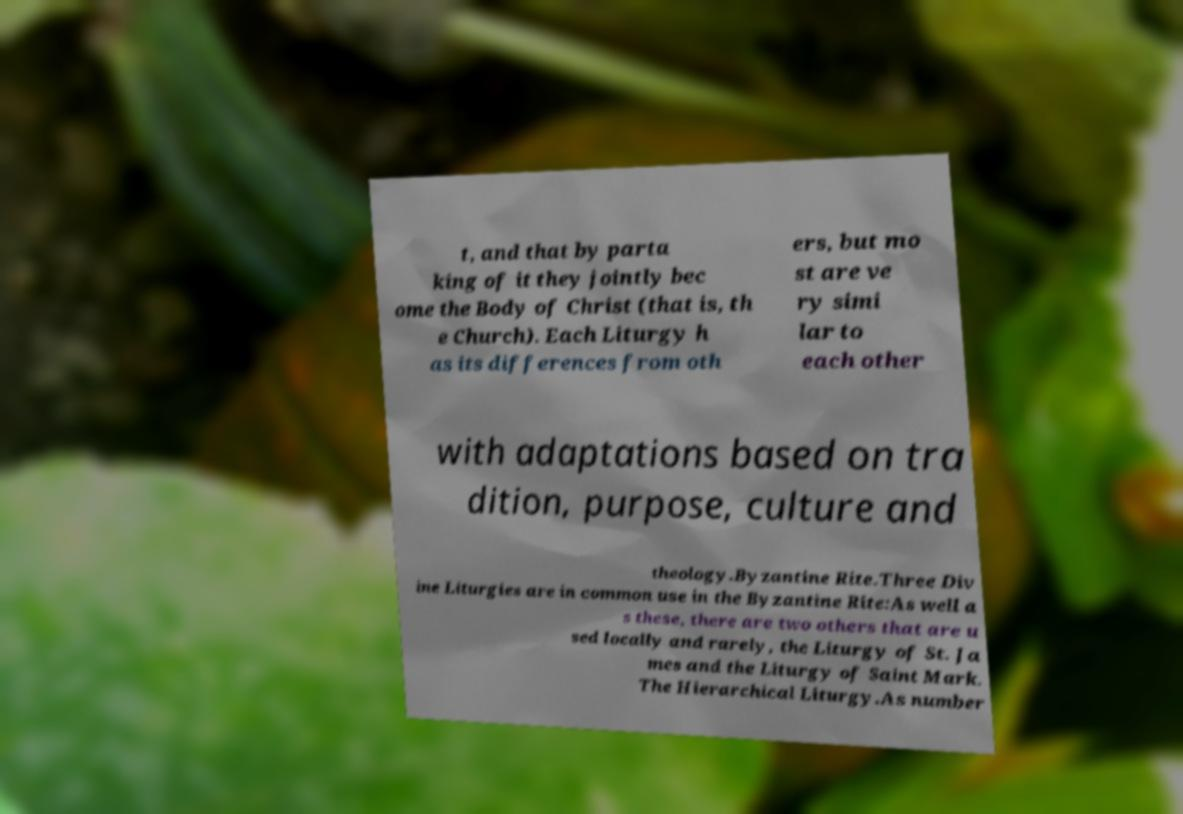Could you extract and type out the text from this image? t, and that by parta king of it they jointly bec ome the Body of Christ (that is, th e Church). Each Liturgy h as its differences from oth ers, but mo st are ve ry simi lar to each other with adaptations based on tra dition, purpose, culture and theology.Byzantine Rite.Three Div ine Liturgies are in common use in the Byzantine Rite:As well a s these, there are two others that are u sed locally and rarely, the Liturgy of St. Ja mes and the Liturgy of Saint Mark. The Hierarchical Liturgy.As number 